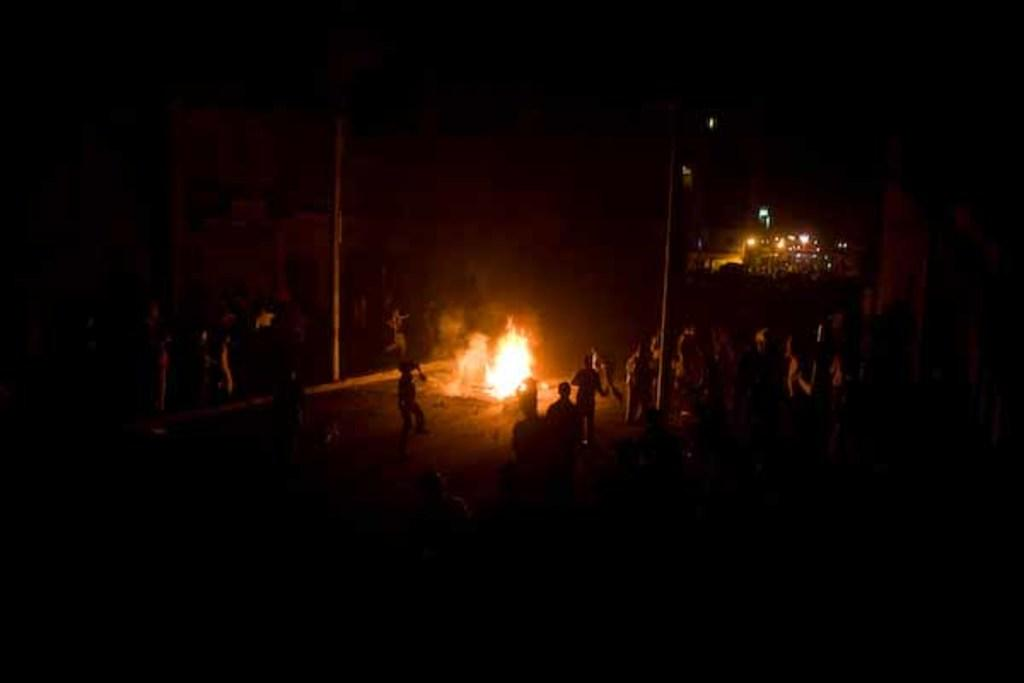What is the main subject of the image? The main subject of the image is a fire in the center. What are the people in the image doing? There is a group of people standing around the fire. What can be observed about the lighting in the image? The background of the image is dark. What type of curtain can be seen hanging from the fire in the image? There is no curtain present in the image; it features a fire with people standing around it. How many sheep are visible in the image? There are no sheep present in the image. 